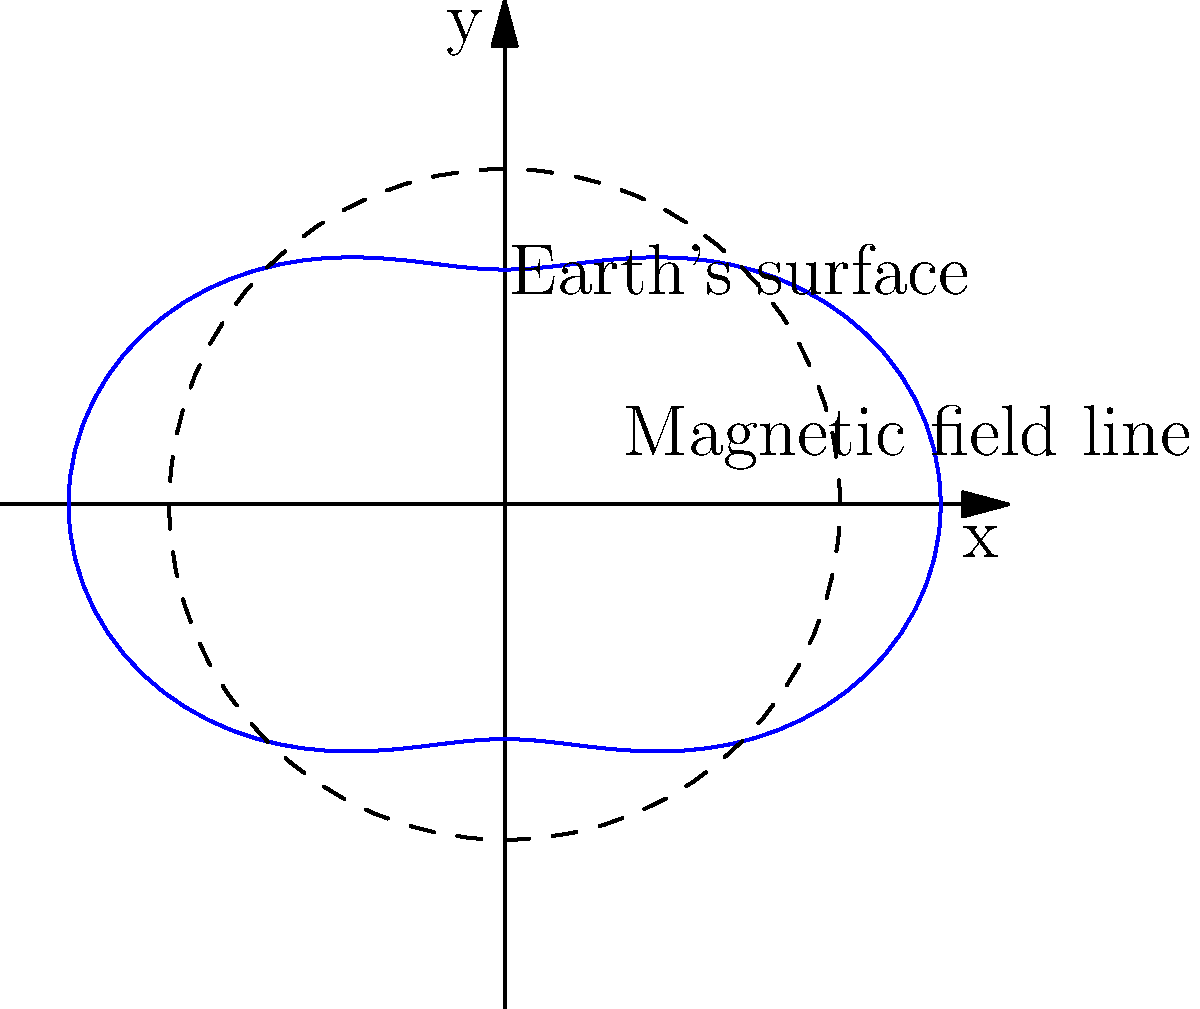In space weather forecasting, the Earth's magnetic field is often represented using polar coordinates. The image shows a simplified 2D model of a magnetic field line described by the equation $r = 1 + 0.3\cos(2\theta)$, where $r$ is in Earth radii. What is the maximum distance (in Earth radii) that this particular magnetic field line reaches from the Earth's center? To find the maximum distance of the magnetic field line from the Earth's center, we need to follow these steps:

1) The equation for the magnetic field line is given as:
   $r = 1 + 0.3\cos(2\theta)$

2) The maximum distance will occur when $\cos(2\theta)$ is at its maximum value, which is 1.

3) Therefore, the maximum $r$ value is:
   $r_{max} = 1 + 0.3(1) = 1.3$

4) This means the magnetic field line reaches a maximum distance of 1.3 Earth radii from the center of the Earth.

5) We can verify this visually from the graph, where we see the blue line (representing the magnetic field) extending beyond the dashed circle (representing the Earth's surface at 1 Earth radius) by about 0.3 units at its furthest point.

This type of representation is crucial in space weather forecasting as it helps visualize how the Earth's magnetic field interacts with solar wind and cosmic rays, which is essential for predicting geomagnetic storms and their potential impacts on satellite operations and ground-based technologies.
Answer: 1.3 Earth radii 